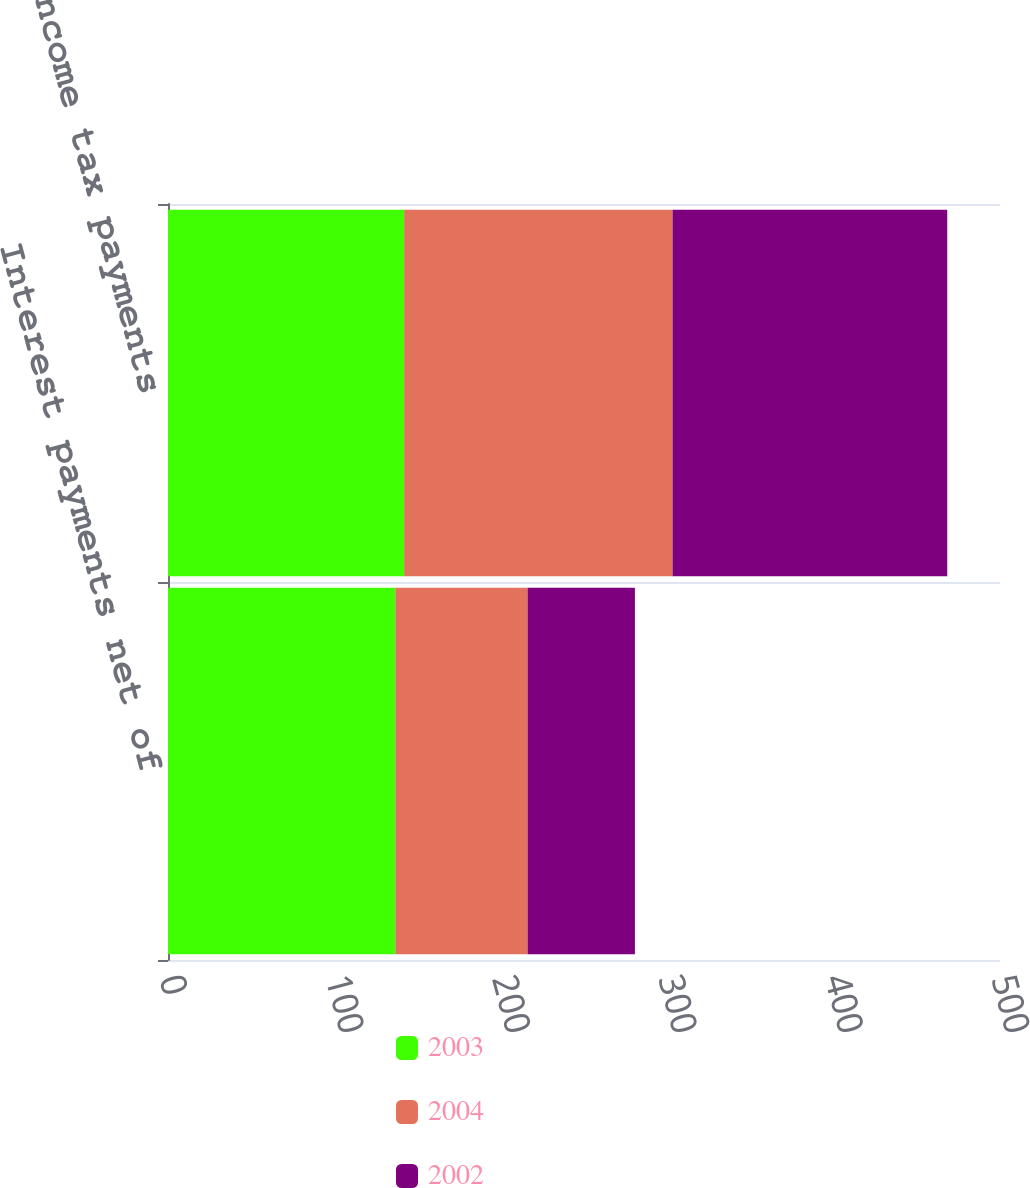<chart> <loc_0><loc_0><loc_500><loc_500><stacked_bar_chart><ecel><fcel>Interest payments net of<fcel>Income tax payments<nl><fcel>2003<fcel>136.6<fcel>141.9<nl><fcel>2004<fcel>79.5<fcel>161.3<nl><fcel>2002<fcel>64.5<fcel>165.1<nl></chart> 